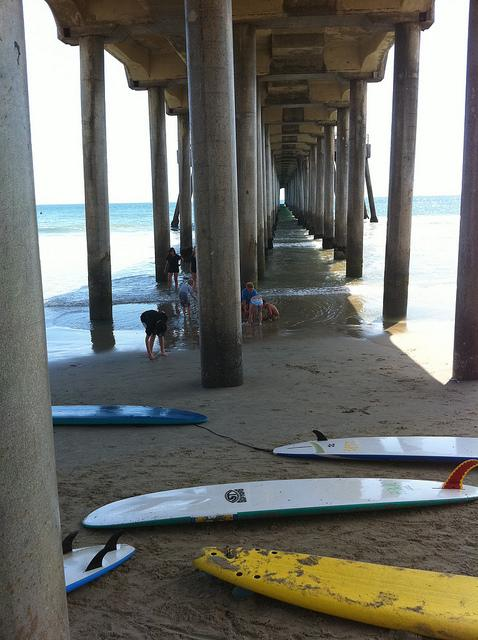What colour is the board on the bottom right?

Choices:
A) green
B) red
C) yellow
D) orange yellow 